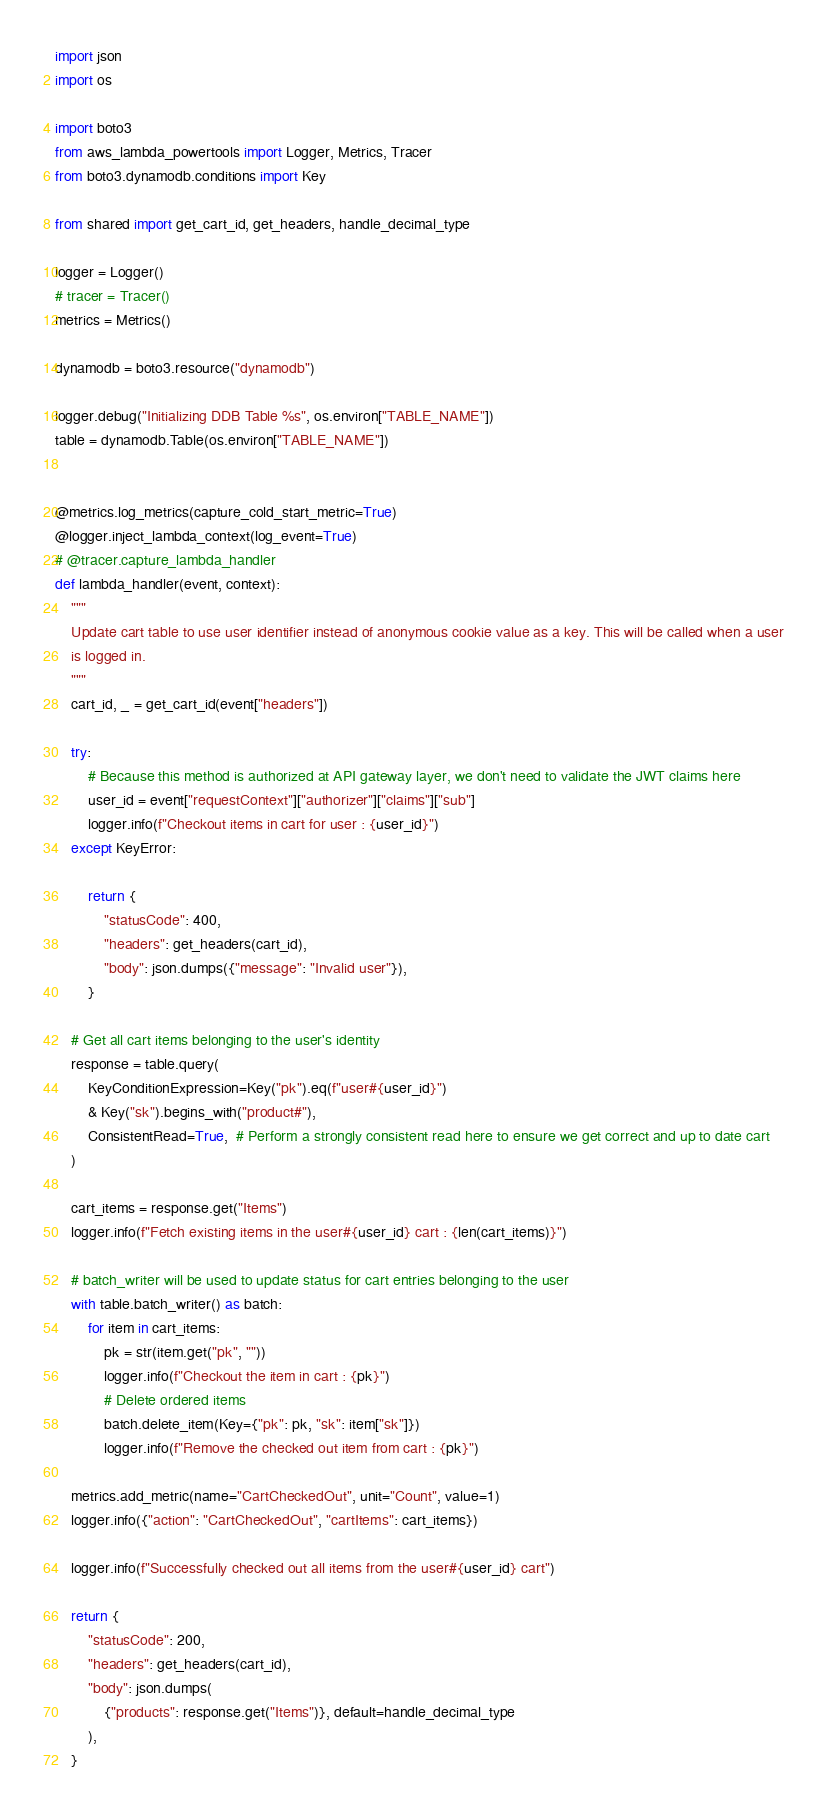Convert code to text. <code><loc_0><loc_0><loc_500><loc_500><_Python_>import json
import os

import boto3
from aws_lambda_powertools import Logger, Metrics, Tracer
from boto3.dynamodb.conditions import Key

from shared import get_cart_id, get_headers, handle_decimal_type

logger = Logger()
# tracer = Tracer()
metrics = Metrics()

dynamodb = boto3.resource("dynamodb")

logger.debug("Initializing DDB Table %s", os.environ["TABLE_NAME"])
table = dynamodb.Table(os.environ["TABLE_NAME"])


@metrics.log_metrics(capture_cold_start_metric=True)
@logger.inject_lambda_context(log_event=True)
# @tracer.capture_lambda_handler
def lambda_handler(event, context):
    """
    Update cart table to use user identifier instead of anonymous cookie value as a key. This will be called when a user
    is logged in.
    """
    cart_id, _ = get_cart_id(event["headers"])

    try:
        # Because this method is authorized at API gateway layer, we don't need to validate the JWT claims here
        user_id = event["requestContext"]["authorizer"]["claims"]["sub"]
        logger.info(f"Checkout items in cart for user : {user_id}")
    except KeyError:

        return {
            "statusCode": 400,
            "headers": get_headers(cart_id),
            "body": json.dumps({"message": "Invalid user"}),
        }

    # Get all cart items belonging to the user's identity
    response = table.query(
        KeyConditionExpression=Key("pk").eq(f"user#{user_id}")
        & Key("sk").begins_with("product#"),
        ConsistentRead=True,  # Perform a strongly consistent read here to ensure we get correct and up to date cart
    )

    cart_items = response.get("Items")
    logger.info(f"Fetch existing items in the user#{user_id} cart : {len(cart_items)}")

    # batch_writer will be used to update status for cart entries belonging to the user
    with table.batch_writer() as batch:
        for item in cart_items:
            pk = str(item.get("pk", ""))
            logger.info(f"Checkout the item in cart : {pk}")
            # Delete ordered items
            batch.delete_item(Key={"pk": pk, "sk": item["sk"]})
            logger.info(f"Remove the checked out item from cart : {pk}")

    metrics.add_metric(name="CartCheckedOut", unit="Count", value=1)
    logger.info({"action": "CartCheckedOut", "cartItems": cart_items})
    
    logger.info(f"Successfully checked out all items from the user#{user_id} cart")

    return {
        "statusCode": 200,
        "headers": get_headers(cart_id),
        "body": json.dumps(
            {"products": response.get("Items")}, default=handle_decimal_type
        ),
    }
</code> 